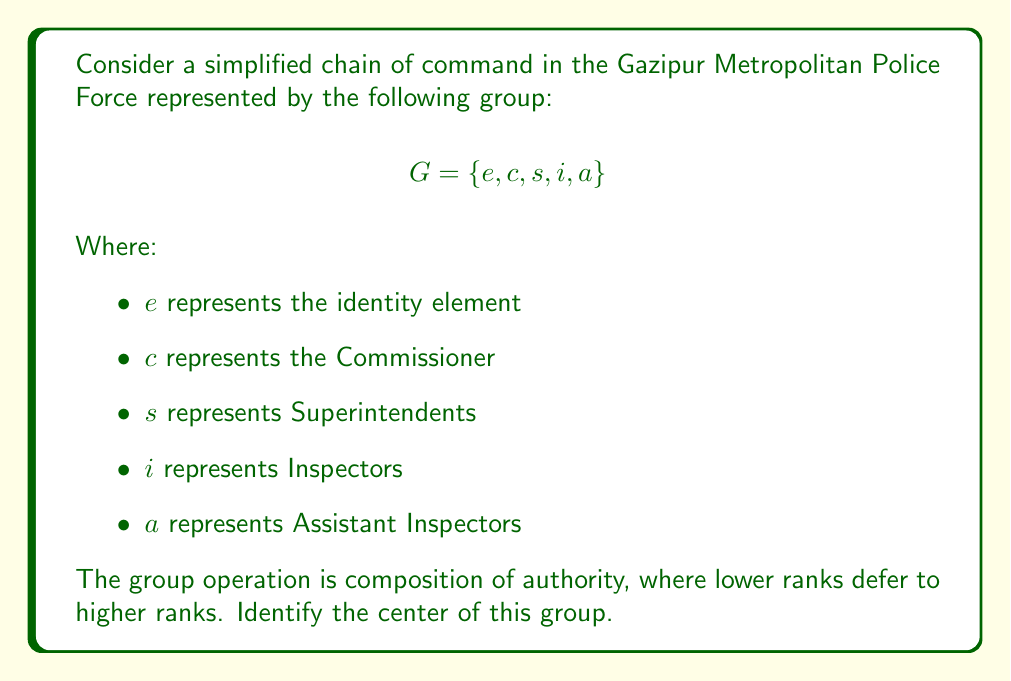Give your solution to this math problem. To find the center of the group, we need to identify all elements that commute with every other element in the group. Let's follow these steps:

1) First, recall that the center of a group $G$ is defined as:
   $$Z(G) = \{z \in G : zg = gz \text{ for all } g \in G\}$$

2) We need to check each element's commutativity with all other elements:

   For $e$:
   - $e$ commutes with all elements (property of identity)

   For $c$:
   - $ce = ec$, $cc = cc$
   - $cs \neq sc$ (Commissioner outranks Superintendent)
   - $ci \neq ic$ (Commissioner outranks Inspector)
   - $ca \neq ac$ (Commissioner outranks Assistant Inspector)

   For $s$:
   - $se = es$, $ss = ss$
   - $sc \neq cs$ (Superintendent is outranked by Commissioner)
   - $si \neq is$ (Superintendent outranks Inspector)
   - $sa \neq as$ (Superintendent outranks Assistant Inspector)

   For $i$:
   - $ie = ei$, $ii = ii$
   - $ic \neq ci$ (Inspector is outranked by Commissioner)
   - $is \neq si$ (Inspector is outranked by Superintendent)
   - $ia \neq ai$ (Inspector outranks Assistant Inspector)

   For $a$:
   - $ae = ea$, $aa = aa$
   - $ac \neq ca$ (Assistant Inspector is outranked by Commissioner)
   - $as \neq sa$ (Assistant Inspector is outranked by Superintendent)
   - $ai \neq ia$ (Assistant Inspector is outranked by Inspector)

3) From this analysis, we can see that only the identity element $e$ commutes with all other elements in the group.

Therefore, the center of the group consists only of the identity element.
Answer: The center of the group is $Z(G) = \{e\}$. 